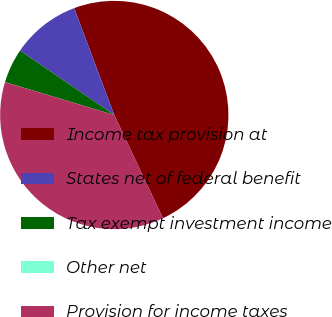Convert chart to OTSL. <chart><loc_0><loc_0><loc_500><loc_500><pie_chart><fcel>Income tax provision at<fcel>States net of federal benefit<fcel>Tax exempt investment income<fcel>Other net<fcel>Provision for income taxes<nl><fcel>48.7%<fcel>9.75%<fcel>4.88%<fcel>0.01%<fcel>36.66%<nl></chart> 